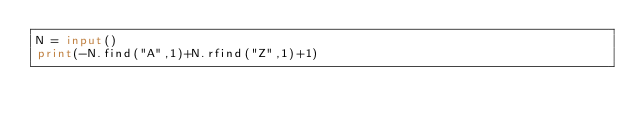<code> <loc_0><loc_0><loc_500><loc_500><_Python_>N = input()
print(-N.find("A",1)+N.rfind("Z",1)+1)
</code> 